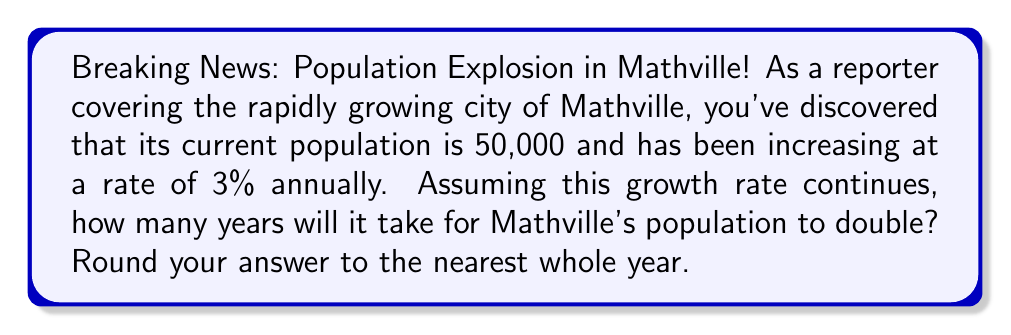Give your solution to this math problem. To solve this problem, we'll use the exponential growth model and the concept of doubling time.

1. The exponential growth model is given by:
   $$P(t) = P_0 \cdot e^{rt}$$
   Where:
   $P(t)$ is the population at time $t$
   $P_0$ is the initial population
   $r$ is the growth rate (as a decimal)
   $t$ is the time in years

2. We want to find $t$ when the population doubles, so:
   $$2P_0 = P_0 \cdot e^{rt}$$

3. Simplify by dividing both sides by $P_0$:
   $$2 = e^{rt}$$

4. Take the natural log of both sides:
   $$\ln(2) = rt$$

5. Solve for $t$:
   $$t = \frac{\ln(2)}{r}$$

6. We know $r = 0.03$ (3% expressed as a decimal), so:
   $$t = \frac{\ln(2)}{0.03}$$

7. Calculate:
   $$t \approx 23.45 \text{ years}$$

8. Rounding to the nearest whole year:
   $$t \approx 23 \text{ years}$$
Answer: 23 years 